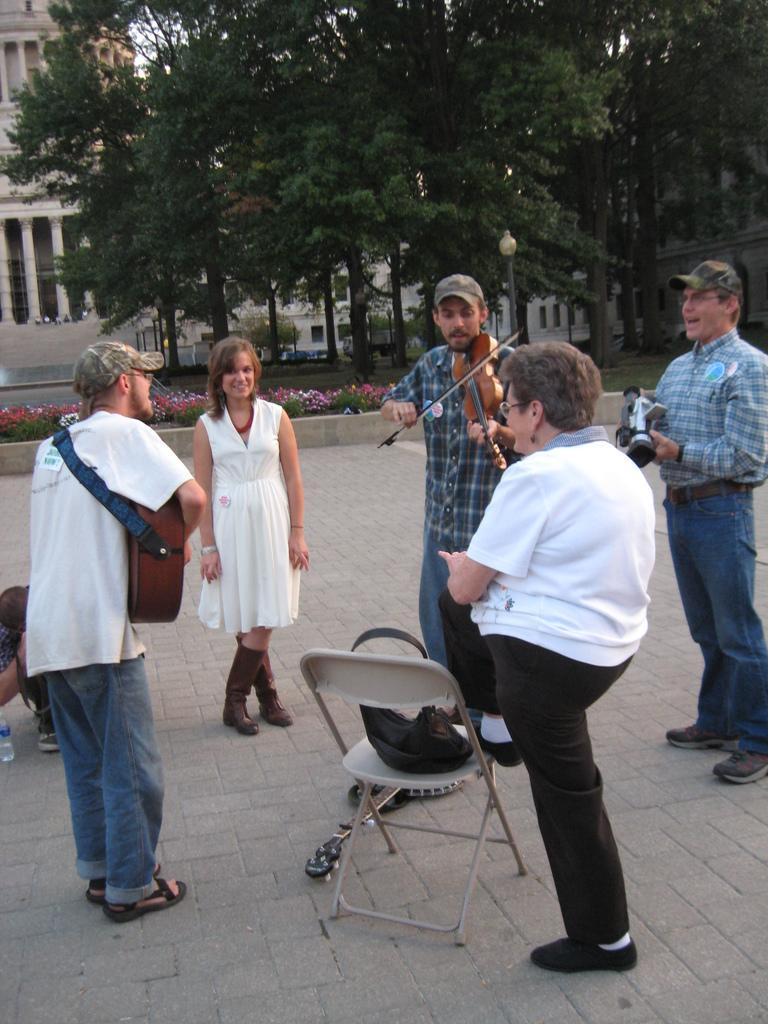In one or two sentences, can you explain what this image depicts? In this picture there is a person standing in the left corner is playing guitar and there is another person standing in front of him is playing violin and there is another person standing in the right corner is holding a camera in his hand and there is a woman placed one of her leg on the chair which is in front of her and there is another woman in front of her and there are trees and buildings in the background. 